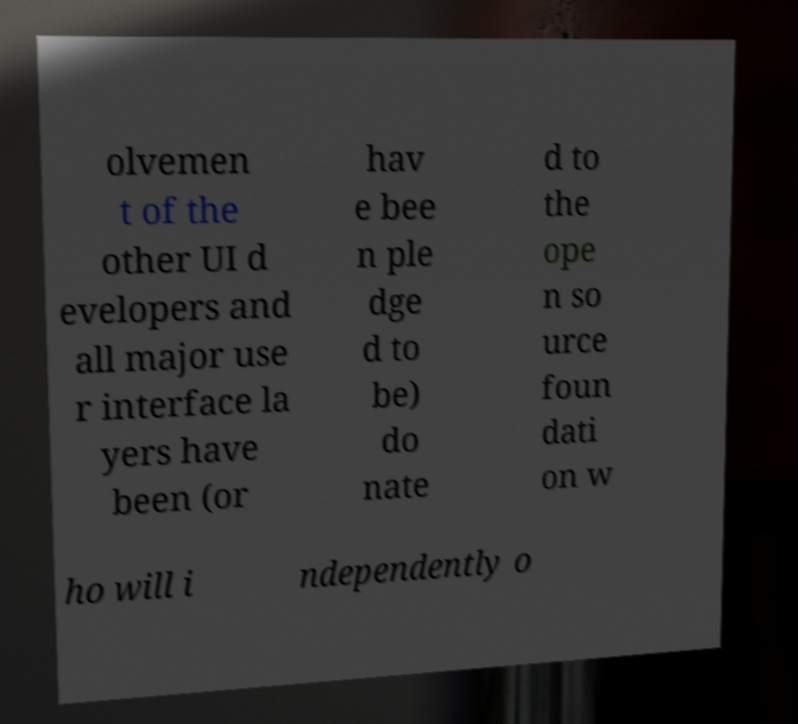There's text embedded in this image that I need extracted. Can you transcribe it verbatim? olvemen t of the other UI d evelopers and all major use r interface la yers have been (or hav e bee n ple dge d to be) do nate d to the ope n so urce foun dati on w ho will i ndependently o 